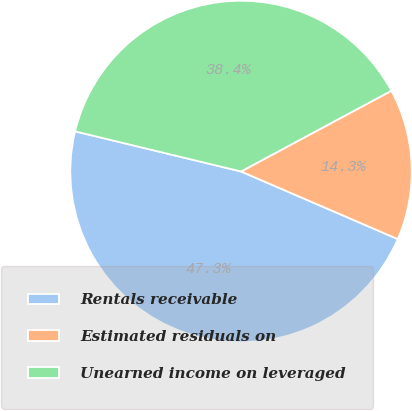Convert chart to OTSL. <chart><loc_0><loc_0><loc_500><loc_500><pie_chart><fcel>Rentals receivable<fcel>Estimated residuals on<fcel>Unearned income on leveraged<nl><fcel>47.29%<fcel>14.32%<fcel>38.38%<nl></chart> 